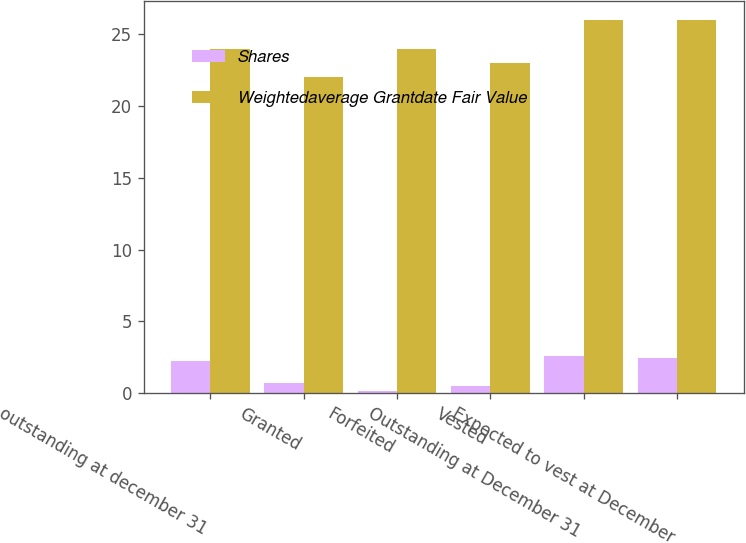<chart> <loc_0><loc_0><loc_500><loc_500><stacked_bar_chart><ecel><fcel>outstanding at december 31<fcel>Granted<fcel>Forfeited<fcel>Vested<fcel>Outstanding at December 31<fcel>Expected to vest at December<nl><fcel>Shares<fcel>2.2<fcel>0.7<fcel>0.1<fcel>0.5<fcel>2.6<fcel>2.4<nl><fcel>Weightedaverage Grantdate Fair Value<fcel>24<fcel>22<fcel>24<fcel>23<fcel>26<fcel>26<nl></chart> 